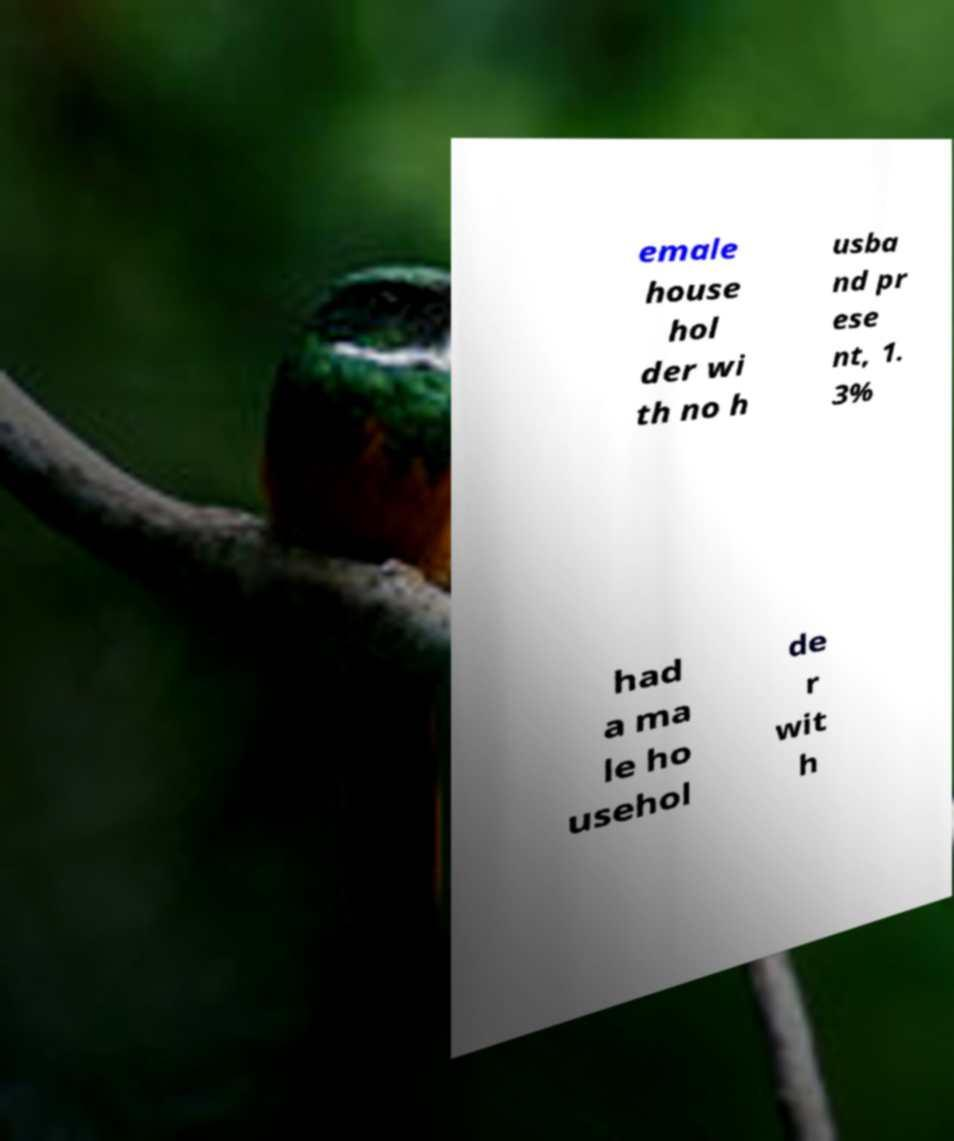What messages or text are displayed in this image? I need them in a readable, typed format. emale house hol der wi th no h usba nd pr ese nt, 1. 3% had a ma le ho usehol de r wit h 